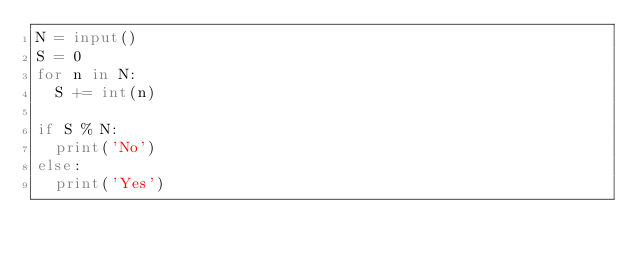Convert code to text. <code><loc_0><loc_0><loc_500><loc_500><_Python_>N = input()
S = 0
for n in N:
  S += int(n)

if S % N:
  print('No')
else:
  print('Yes')</code> 